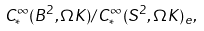Convert formula to latex. <formula><loc_0><loc_0><loc_500><loc_500>C ^ { \infty } _ { * } ( B ^ { 2 } , \Omega K ) / C _ { * } ^ { \infty } ( S ^ { 2 } , \Omega K ) _ { e } ,</formula> 